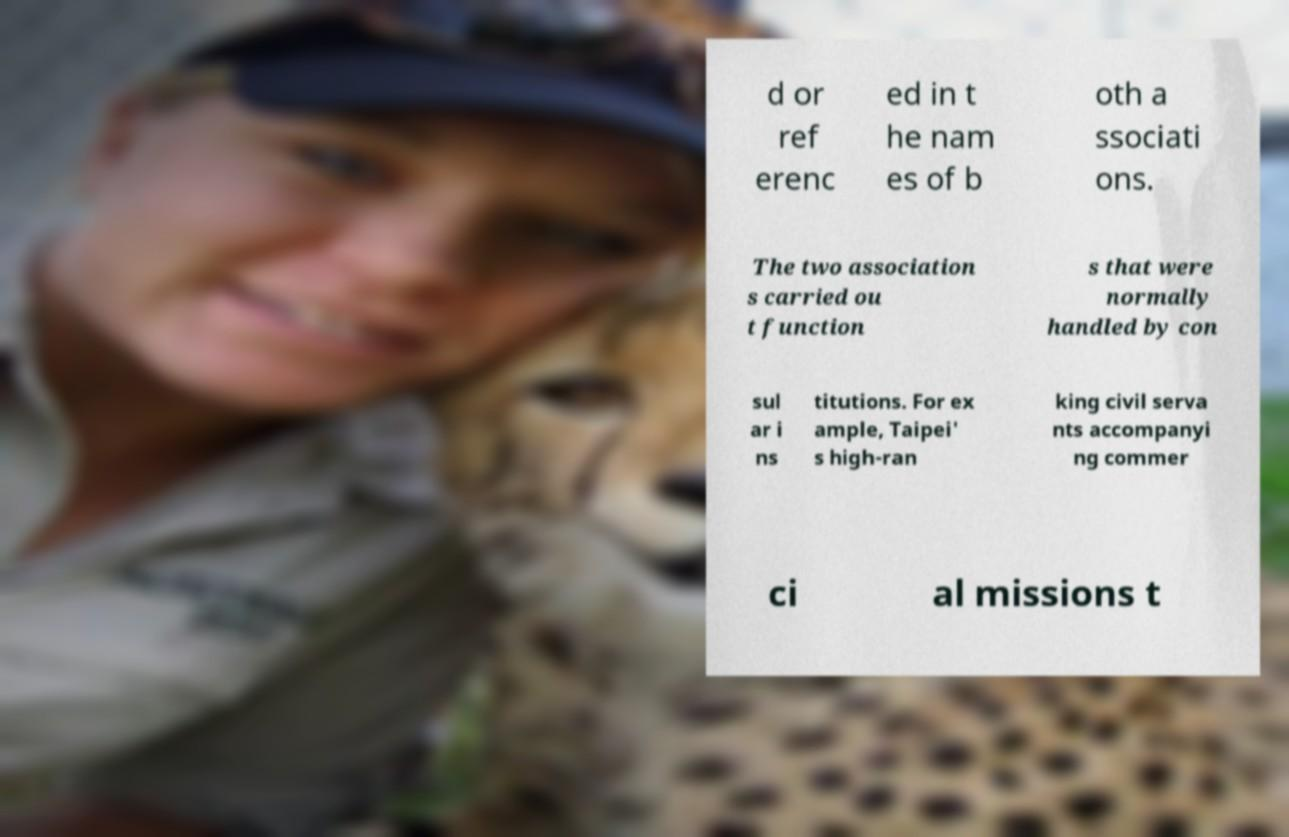I need the written content from this picture converted into text. Can you do that? d or ref erenc ed in t he nam es of b oth a ssociati ons. The two association s carried ou t function s that were normally handled by con sul ar i ns titutions. For ex ample, Taipei' s high-ran king civil serva nts accompanyi ng commer ci al missions t 